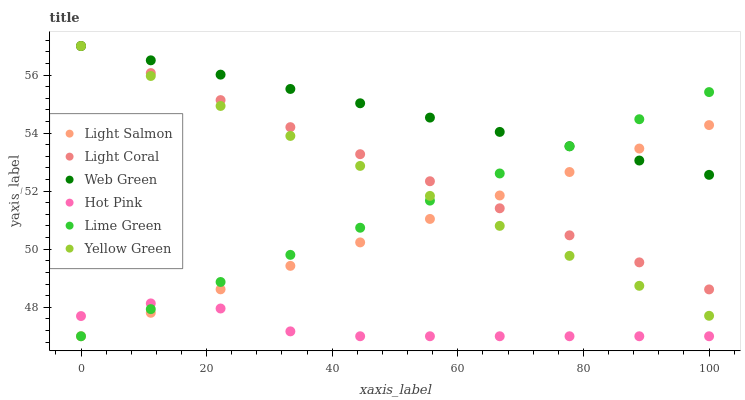Does Hot Pink have the minimum area under the curve?
Answer yes or no. Yes. Does Web Green have the maximum area under the curve?
Answer yes or no. Yes. Does Yellow Green have the minimum area under the curve?
Answer yes or no. No. Does Yellow Green have the maximum area under the curve?
Answer yes or no. No. Is Yellow Green the smoothest?
Answer yes or no. Yes. Is Hot Pink the roughest?
Answer yes or no. Yes. Is Hot Pink the smoothest?
Answer yes or no. No. Is Yellow Green the roughest?
Answer yes or no. No. Does Light Salmon have the lowest value?
Answer yes or no. Yes. Does Yellow Green have the lowest value?
Answer yes or no. No. Does Light Coral have the highest value?
Answer yes or no. Yes. Does Hot Pink have the highest value?
Answer yes or no. No. Is Hot Pink less than Yellow Green?
Answer yes or no. Yes. Is Light Coral greater than Hot Pink?
Answer yes or no. Yes. Does Web Green intersect Yellow Green?
Answer yes or no. Yes. Is Web Green less than Yellow Green?
Answer yes or no. No. Is Web Green greater than Yellow Green?
Answer yes or no. No. Does Hot Pink intersect Yellow Green?
Answer yes or no. No. 